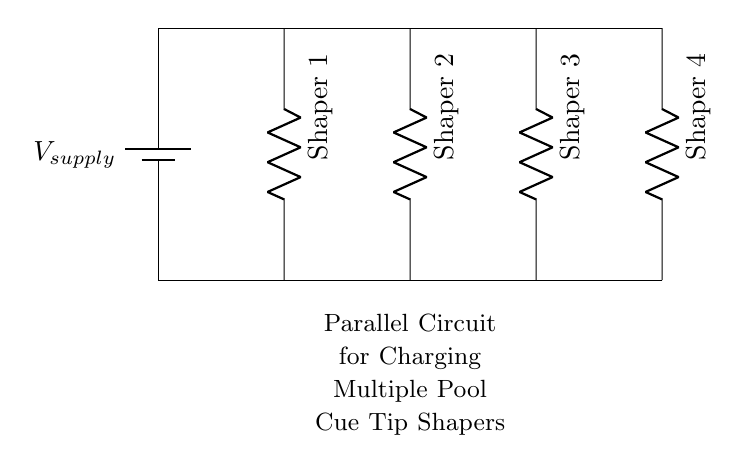What type of circuit is shown? The circuit diagram depicts a parallel circuit, where multiple components are connected across the same voltage source. This is defined by the layout, allowing each shaper to operate independently while sharing the same voltage supply.
Answer: Parallel How many shapers are shown in the circuit? The diagram illustrates a total of four shapers, labeled Shaper 1 through Shaper 4, arranged in parallel across the supply voltage.
Answer: Four What is the function of the battery in this circuit? The battery serves as the voltage supply, providing the necessary electrical energy to charge all connected pool cue tip shapers simultaneously. It is represented at the top of the circuit as a voltage source.
Answer: Voltage supply Are the resistors in series or parallel? The resistors representing the shapers are arranged in parallel, as they each connect directly to the same two points and share the same voltage. This configuration allows each resistor to operate independently.
Answer: Parallel What is the total voltage across each shaper? Each shaper receives the same voltage supply as shown; in this case, it is the voltage output of the battery applied directly across each one.
Answer: V supply What happens to the total current in the circuit when more shapers are added? Adding more shapers in parallel increases the total current drawn from the voltage supply, as each shaper provides an additional path for current flow, effectively lowering the total equivalent resistance of the circuit.
Answer: Increases If one shaper fails, what happens to the others? In a parallel circuit design, if one shaper fails, the other shapers continue to operate normally, as they are connected independently to the voltage supply. This is a key benefit of parallel configurations.
Answer: Others continue working 